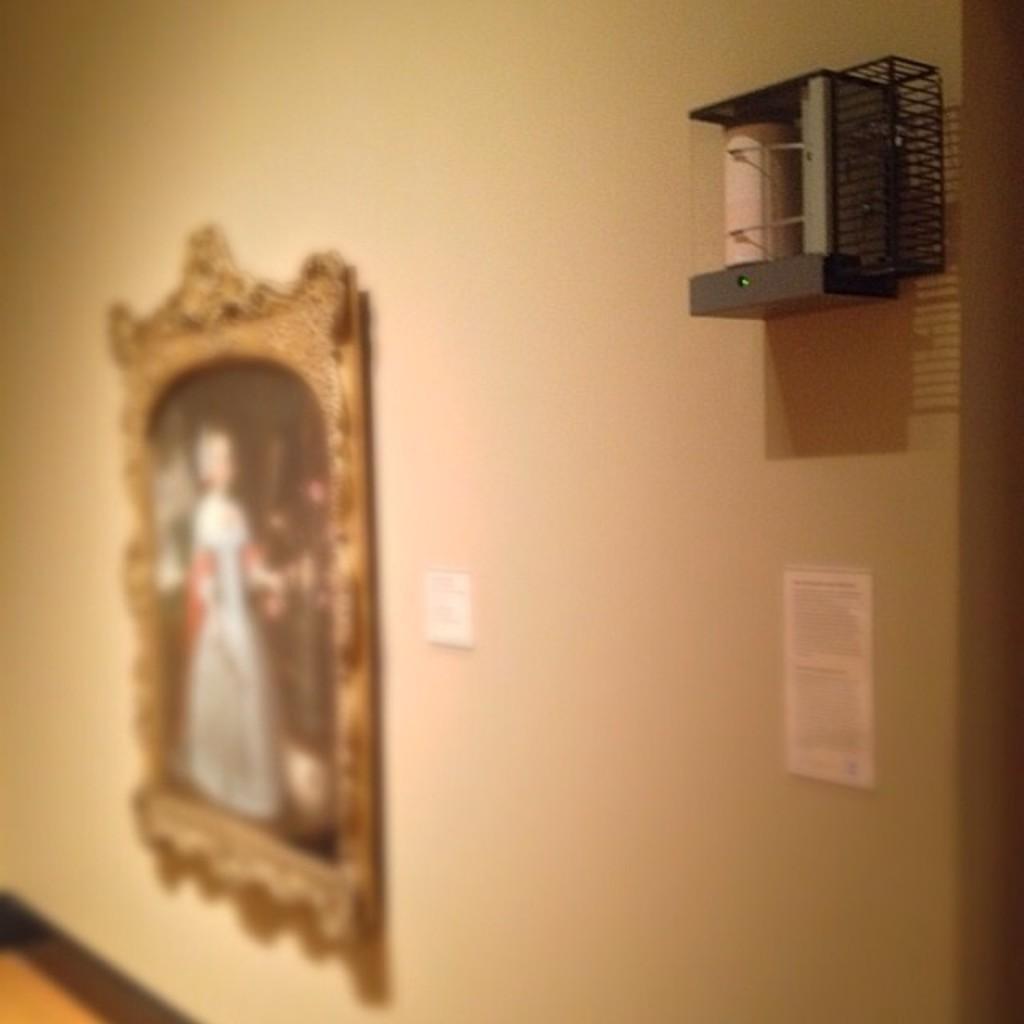Describe this image in one or two sentences. In this picture I can see a frame, papers and an object attached to the wall. 